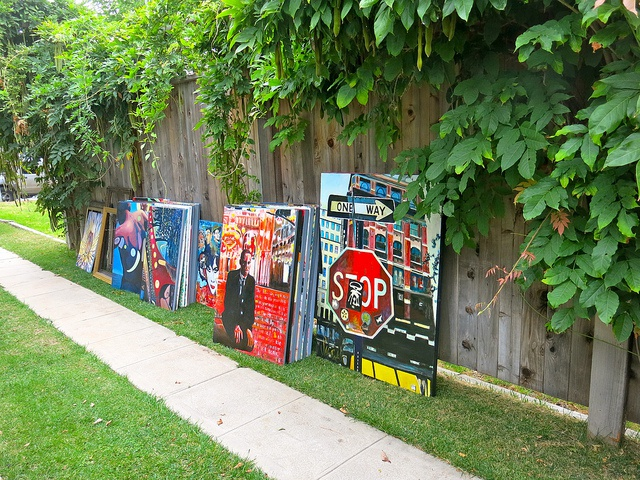Describe the objects in this image and their specific colors. I can see book in darkgreen, white, red, salmon, and gray tones, stop sign in darkgreen, red, ivory, brown, and maroon tones, book in darkgreen, gray, blue, and brown tones, book in darkgreen, gray, blue, lightblue, and lightpink tones, and people in darkgreen, black, and gray tones in this image. 